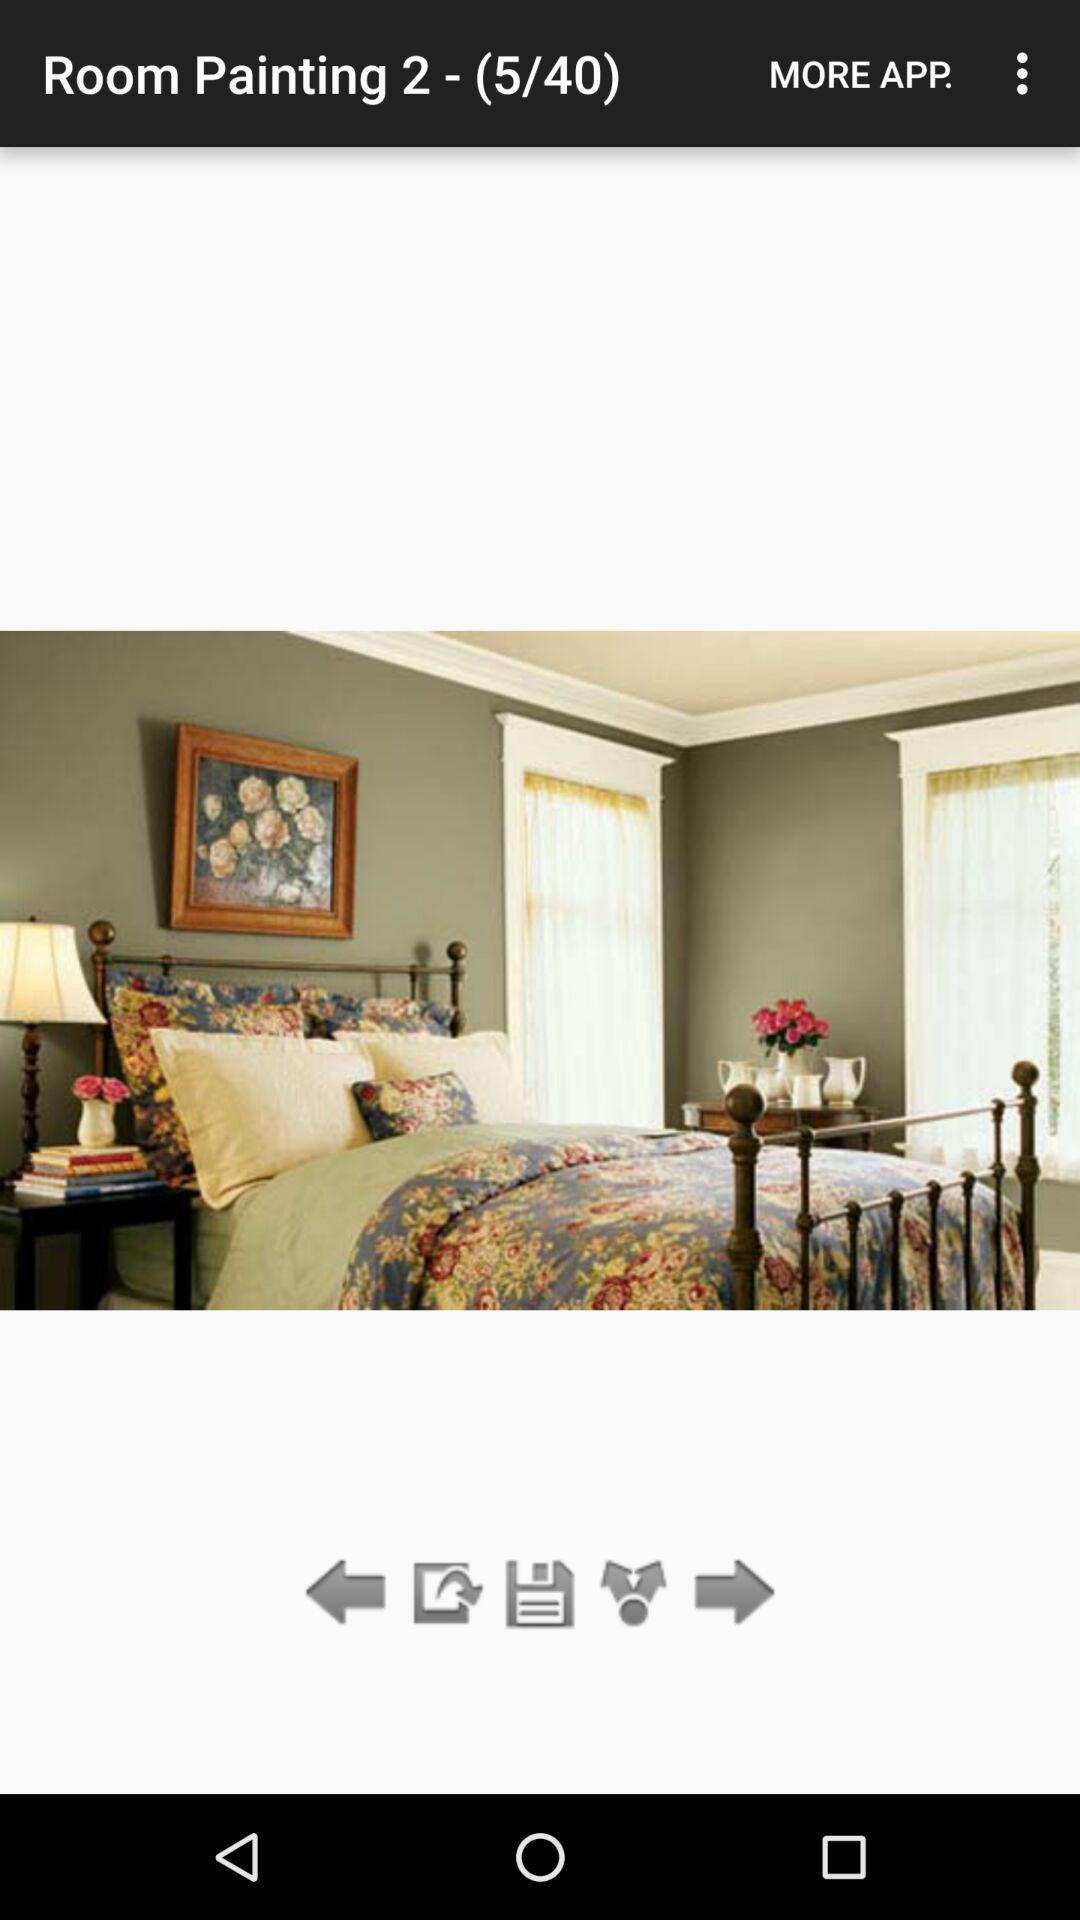How many slides in total are there? There are 40 slides in total. 